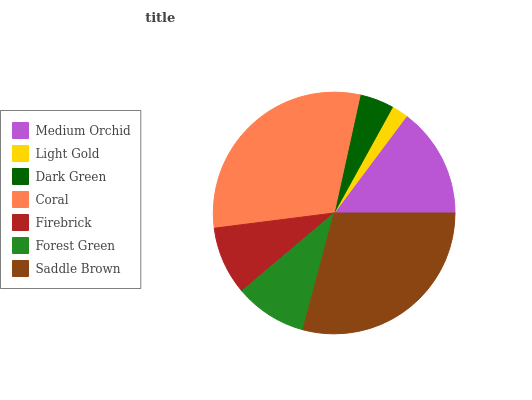Is Light Gold the minimum?
Answer yes or no. Yes. Is Coral the maximum?
Answer yes or no. Yes. Is Dark Green the minimum?
Answer yes or no. No. Is Dark Green the maximum?
Answer yes or no. No. Is Dark Green greater than Light Gold?
Answer yes or no. Yes. Is Light Gold less than Dark Green?
Answer yes or no. Yes. Is Light Gold greater than Dark Green?
Answer yes or no. No. Is Dark Green less than Light Gold?
Answer yes or no. No. Is Forest Green the high median?
Answer yes or no. Yes. Is Forest Green the low median?
Answer yes or no. Yes. Is Saddle Brown the high median?
Answer yes or no. No. Is Saddle Brown the low median?
Answer yes or no. No. 